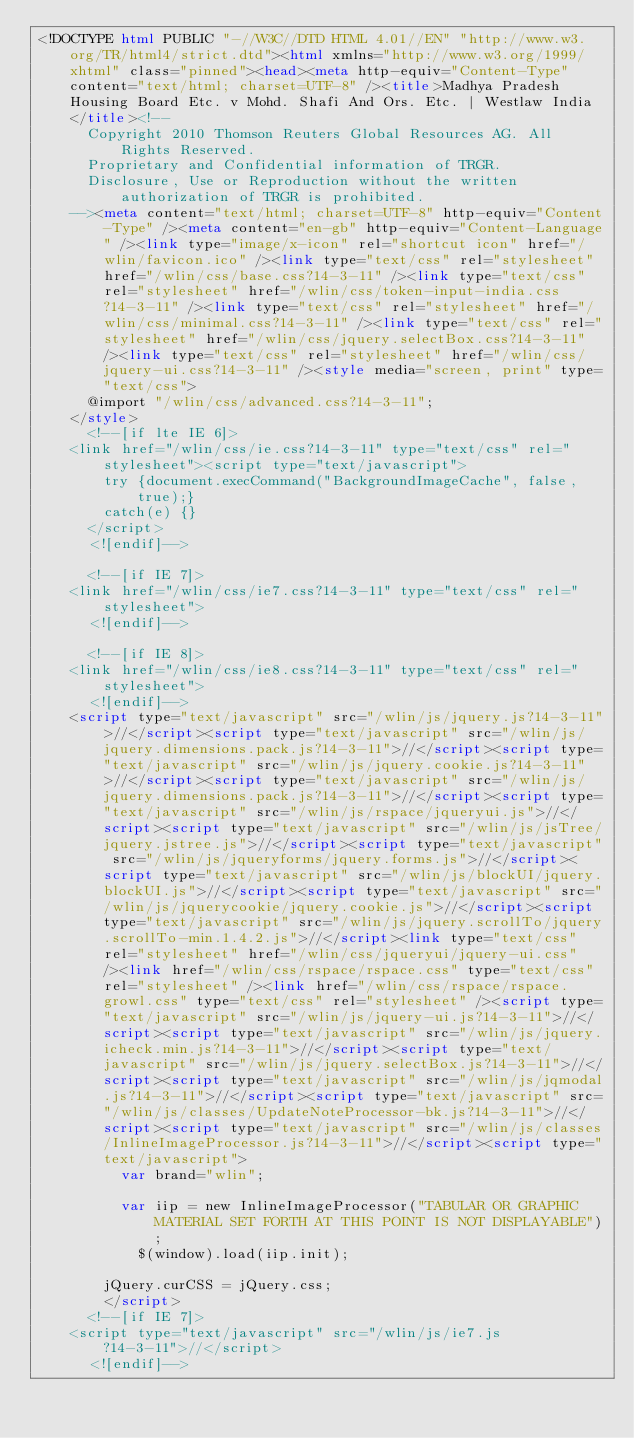Convert code to text. <code><loc_0><loc_0><loc_500><loc_500><_HTML_><!DOCTYPE html PUBLIC "-//W3C//DTD HTML 4.01//EN" "http://www.w3.org/TR/html4/strict.dtd"><html xmlns="http://www.w3.org/1999/xhtml" class="pinned"><head><meta http-equiv="Content-Type" content="text/html; charset=UTF-8" /><title>Madhya Pradesh Housing Board Etc. v Mohd. Shafi And Ors. Etc. | Westlaw India</title><!--
      Copyright 2010 Thomson Reuters Global Resources AG. All Rights Reserved.
      Proprietary and Confidential information of TRGR.
      Disclosure, Use or Reproduction without the written authorization of TRGR is prohibited.
    --><meta content="text/html; charset=UTF-8" http-equiv="Content-Type" /><meta content="en-gb" http-equiv="Content-Language" /><link type="image/x-icon" rel="shortcut icon" href="/wlin/favicon.ico" /><link type="text/css" rel="stylesheet" href="/wlin/css/base.css?14-3-11" /><link type="text/css" rel="stylesheet" href="/wlin/css/token-input-india.css?14-3-11" /><link type="text/css" rel="stylesheet" href="/wlin/css/minimal.css?14-3-11" /><link type="text/css" rel="stylesheet" href="/wlin/css/jquery.selectBox.css?14-3-11" /><link type="text/css" rel="stylesheet" href="/wlin/css/jquery-ui.css?14-3-11" /><style media="screen, print" type="text/css">
			@import "/wlin/css/advanced.css?14-3-11";
		</style>
			<!--[if lte IE 6]>
		<link href="/wlin/css/ie.css?14-3-11" type="text/css" rel="stylesheet"><script type="text/javascript">
				try {document.execCommand("BackgroundImageCache", false, true);}
				catch(e) {}
			</script>
			<![endif]-->
		
			<!--[if IE 7]>
		<link href="/wlin/css/ie7.css?14-3-11" type="text/css" rel="stylesheet">
			<![endif]-->
		
			<!--[if IE 8]>
		<link href="/wlin/css/ie8.css?14-3-11" type="text/css" rel="stylesheet">
			<![endif]-->
		<script type="text/javascript" src="/wlin/js/jquery.js?14-3-11">//</script><script type="text/javascript" src="/wlin/js/jquery.dimensions.pack.js?14-3-11">//</script><script type="text/javascript" src="/wlin/js/jquery.cookie.js?14-3-11">//</script><script type="text/javascript" src="/wlin/js/jquery.dimensions.pack.js?14-3-11">//</script><script type="text/javascript" src="/wlin/js/rspace/jqueryui.js">//</script><script type="text/javascript" src="/wlin/js/jsTree/jquery.jstree.js">//</script><script type="text/javascript" src="/wlin/js/jqueryforms/jquery.forms.js">//</script><script type="text/javascript" src="/wlin/js/blockUI/jquery.blockUI.js">//</script><script type="text/javascript" src="/wlin/js/jquerycookie/jquery.cookie.js">//</script><script type="text/javascript" src="/wlin/js/jquery.scrollTo/jquery.scrollTo-min.1.4.2.js">//</script><link type="text/css" rel="stylesheet" href="/wlin/css/jqueryui/jquery-ui.css" /><link href="/wlin/css/rspace/rspace.css" type="text/css" rel="stylesheet" /><link href="/wlin/css/rspace/rspace.growl.css" type="text/css" rel="stylesheet" /><script type="text/javascript" src="/wlin/js/jquery-ui.js?14-3-11">//</script><script type="text/javascript" src="/wlin/js/jquery.icheck.min.js?14-3-11">//</script><script type="text/javascript" src="/wlin/js/jquery.selectBox.js?14-3-11">//</script><script type="text/javascript" src="/wlin/js/jqmodal.js?14-3-11">//</script><script type="text/javascript" src="/wlin/js/classes/UpdateNoteProcessor-bk.js?14-3-11">//</script><script type="text/javascript" src="/wlin/js/classes/InlineImageProcessor.js?14-3-11">//</script><script type="text/javascript">
        	var brand="wlin";
        	
        	var iip = new InlineImageProcessor("TABULAR OR GRAPHIC MATERIAL SET FORTH AT THIS POINT IS NOT DISPLAYABLE"); 
            $(window).load(iip.init);
            
    		jQuery.curCSS = jQuery.css;
        </script>
			<!--[if IE 7]>
		<script type="text/javascript" src="/wlin/js/ie7.js?14-3-11">//</script>
			<![endif]--></code> 